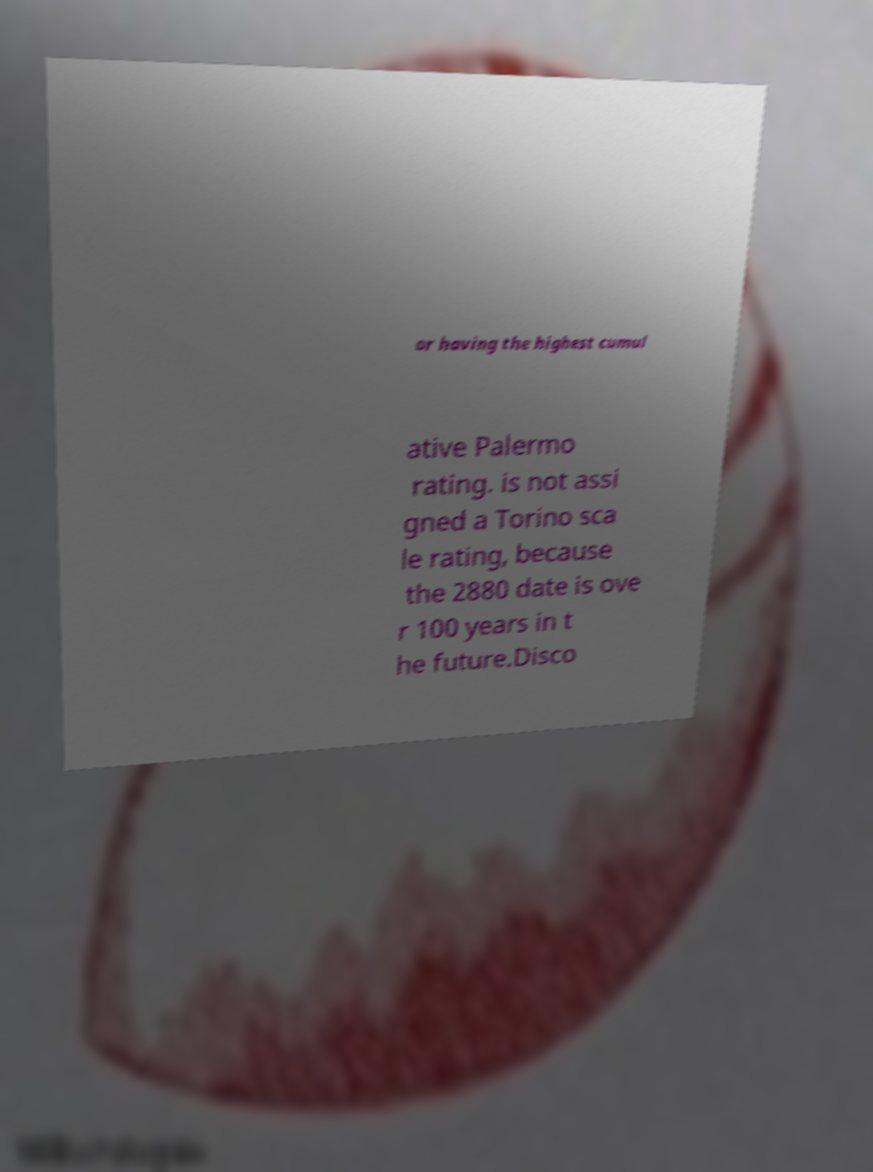There's text embedded in this image that I need extracted. Can you transcribe it verbatim? or having the highest cumul ative Palermo rating. is not assi gned a Torino sca le rating, because the 2880 date is ove r 100 years in t he future.Disco 